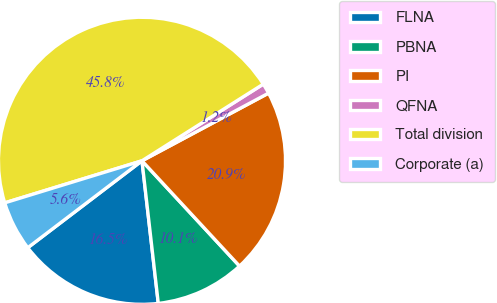Convert chart. <chart><loc_0><loc_0><loc_500><loc_500><pie_chart><fcel>FLNA<fcel>PBNA<fcel>PI<fcel>QFNA<fcel>Total division<fcel>Corporate (a)<nl><fcel>16.46%<fcel>10.08%<fcel>20.92%<fcel>1.16%<fcel>45.76%<fcel>5.62%<nl></chart> 